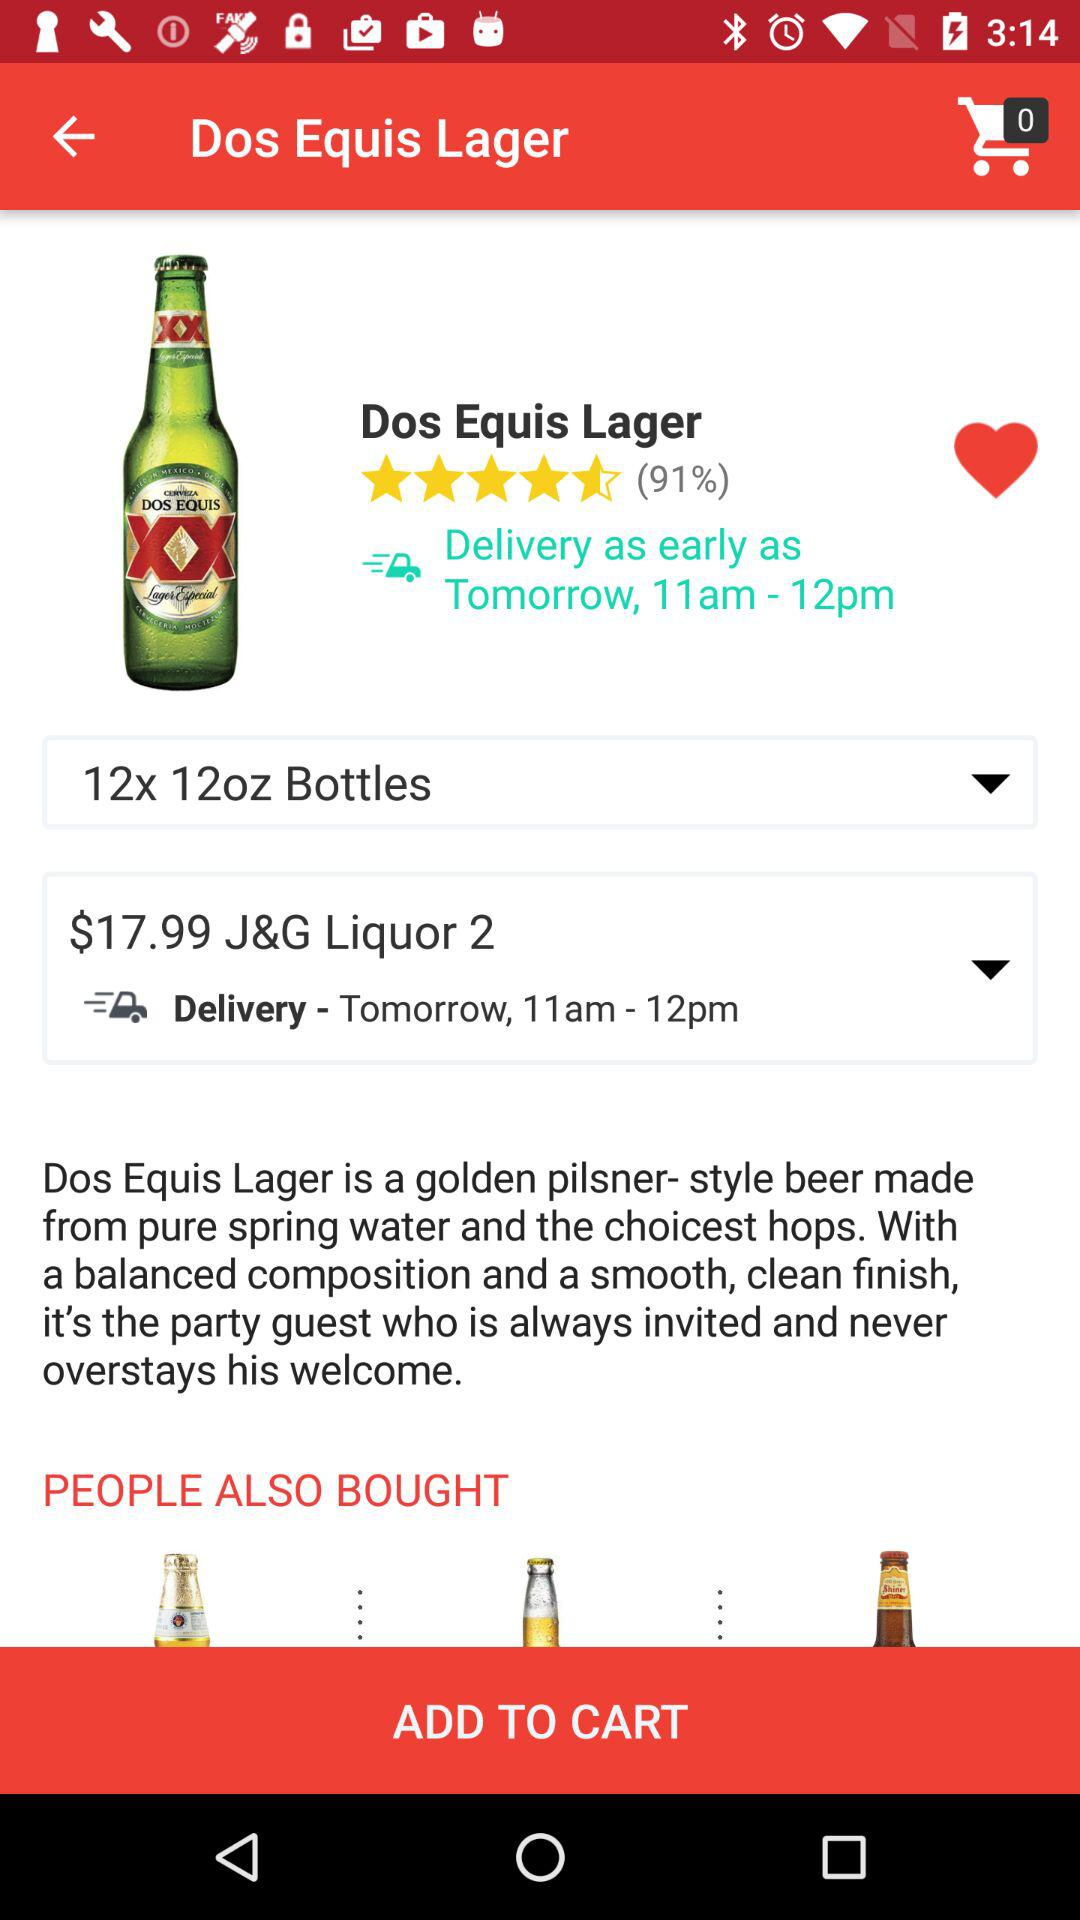What is the delivery timing? The delivery timing is from 11 a.m. to 12 p.m. 